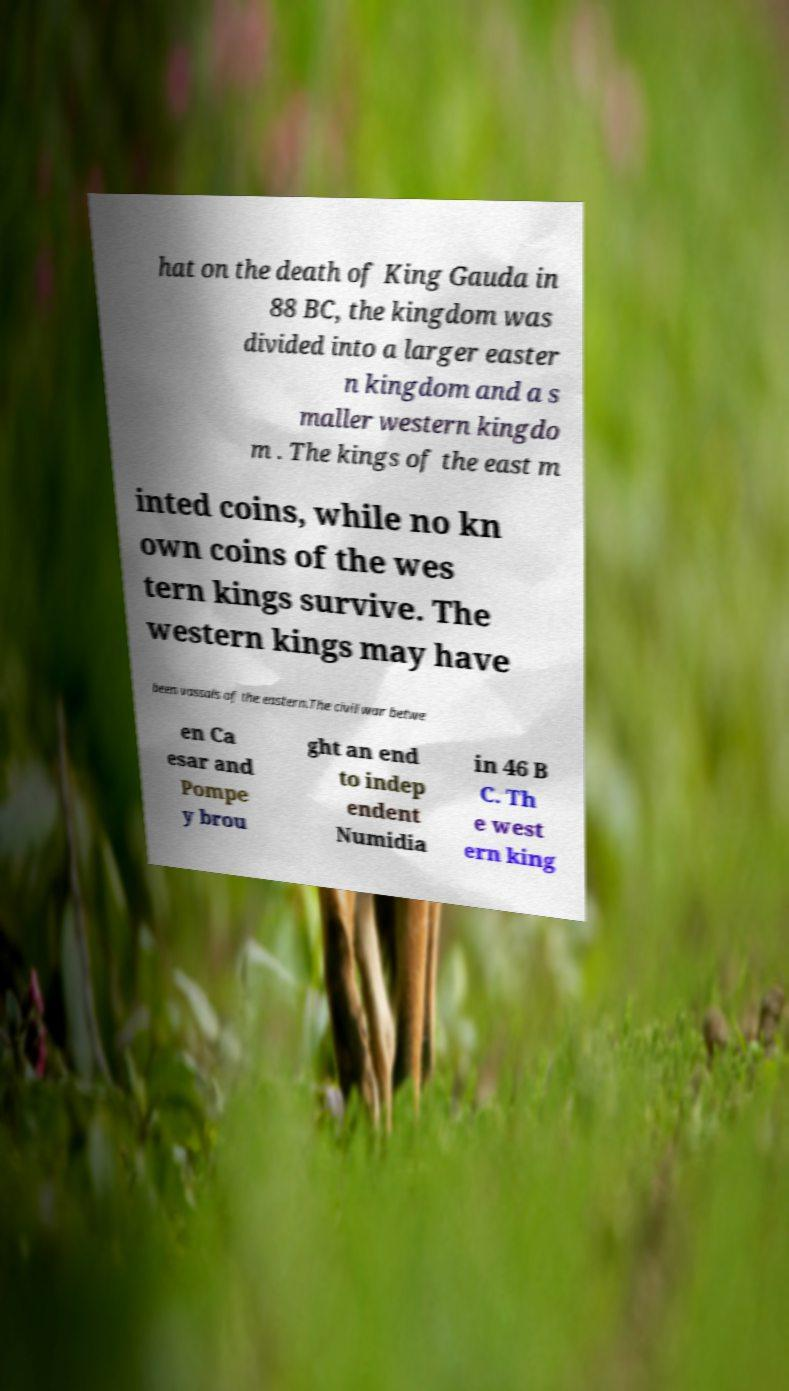There's text embedded in this image that I need extracted. Can you transcribe it verbatim? hat on the death of King Gauda in 88 BC, the kingdom was divided into a larger easter n kingdom and a s maller western kingdo m . The kings of the east m inted coins, while no kn own coins of the wes tern kings survive. The western kings may have been vassals of the eastern.The civil war betwe en Ca esar and Pompe y brou ght an end to indep endent Numidia in 46 B C. Th e west ern king 